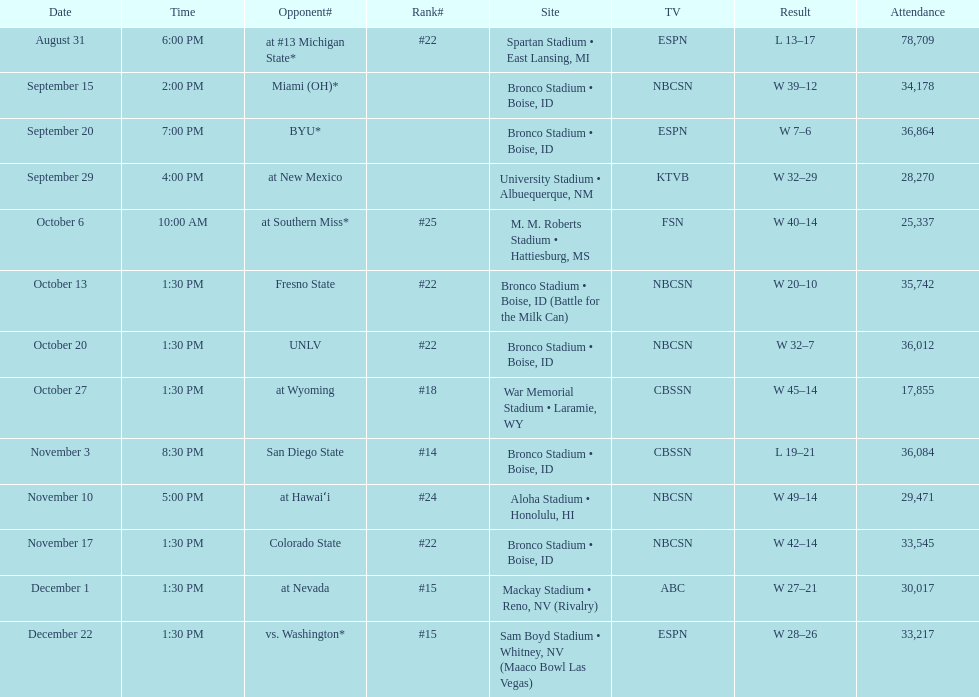Help me parse the entirety of this table. {'header': ['Date', 'Time', 'Opponent#', 'Rank#', 'Site', 'TV', 'Result', 'Attendance'], 'rows': [['August 31', '6:00 PM', 'at\xa0#13\xa0Michigan State*', '#22', 'Spartan Stadium • East Lansing, MI', 'ESPN', 'L\xa013–17', '78,709'], ['September 15', '2:00 PM', 'Miami (OH)*', '', 'Bronco Stadium • Boise, ID', 'NBCSN', 'W\xa039–12', '34,178'], ['September 20', '7:00 PM', 'BYU*', '', 'Bronco Stadium • Boise, ID', 'ESPN', 'W\xa07–6', '36,864'], ['September 29', '4:00 PM', 'at\xa0New Mexico', '', 'University Stadium • Albuequerque, NM', 'KTVB', 'W\xa032–29', '28,270'], ['October 6', '10:00 AM', 'at\xa0Southern Miss*', '#25', 'M. M. Roberts Stadium • Hattiesburg, MS', 'FSN', 'W\xa040–14', '25,337'], ['October 13', '1:30 PM', 'Fresno State', '#22', 'Bronco Stadium • Boise, ID (Battle for the Milk Can)', 'NBCSN', 'W\xa020–10', '35,742'], ['October 20', '1:30 PM', 'UNLV', '#22', 'Bronco Stadium • Boise, ID', 'NBCSN', 'W\xa032–7', '36,012'], ['October 27', '1:30 PM', 'at\xa0Wyoming', '#18', 'War Memorial Stadium • Laramie, WY', 'CBSSN', 'W\xa045–14', '17,855'], ['November 3', '8:30 PM', 'San Diego State', '#14', 'Bronco Stadium • Boise, ID', 'CBSSN', 'L\xa019–21', '36,084'], ['November 10', '5:00 PM', 'at\xa0Hawaiʻi', '#24', 'Aloha Stadium • Honolulu, HI', 'NBCSN', 'W\xa049–14', '29,471'], ['November 17', '1:30 PM', 'Colorado State', '#22', 'Bronco Stadium • Boise, ID', 'NBCSN', 'W\xa042–14', '33,545'], ['December 1', '1:30 PM', 'at\xa0Nevada', '#15', 'Mackay Stadium • Reno, NV (Rivalry)', 'ABC', 'W\xa027–21', '30,017'], ['December 22', '1:30 PM', 'vs.\xa0Washington*', '#15', 'Sam Boyd Stadium • Whitney, NV (Maaco Bowl Las Vegas)', 'ESPN', 'W\xa028–26', '33,217']]} Which team did the broncos play against following their match with unlv? Wyoming. 